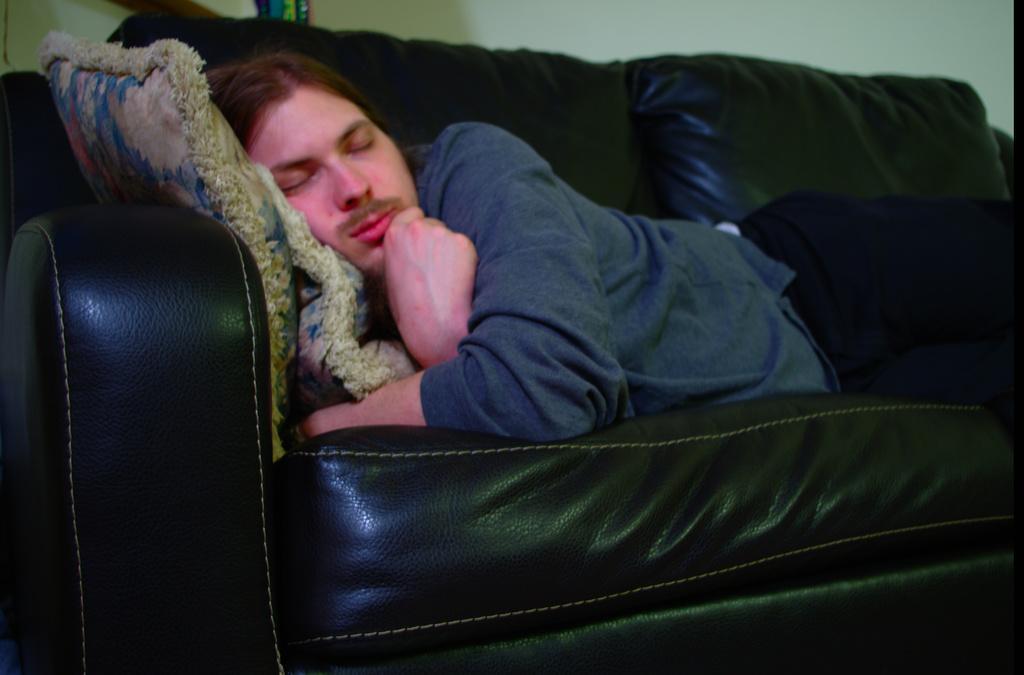In one or two sentences, can you explain what this image depicts? In this image I can see a man is lying on a sofa. I can also see few cushions on this sofa. 